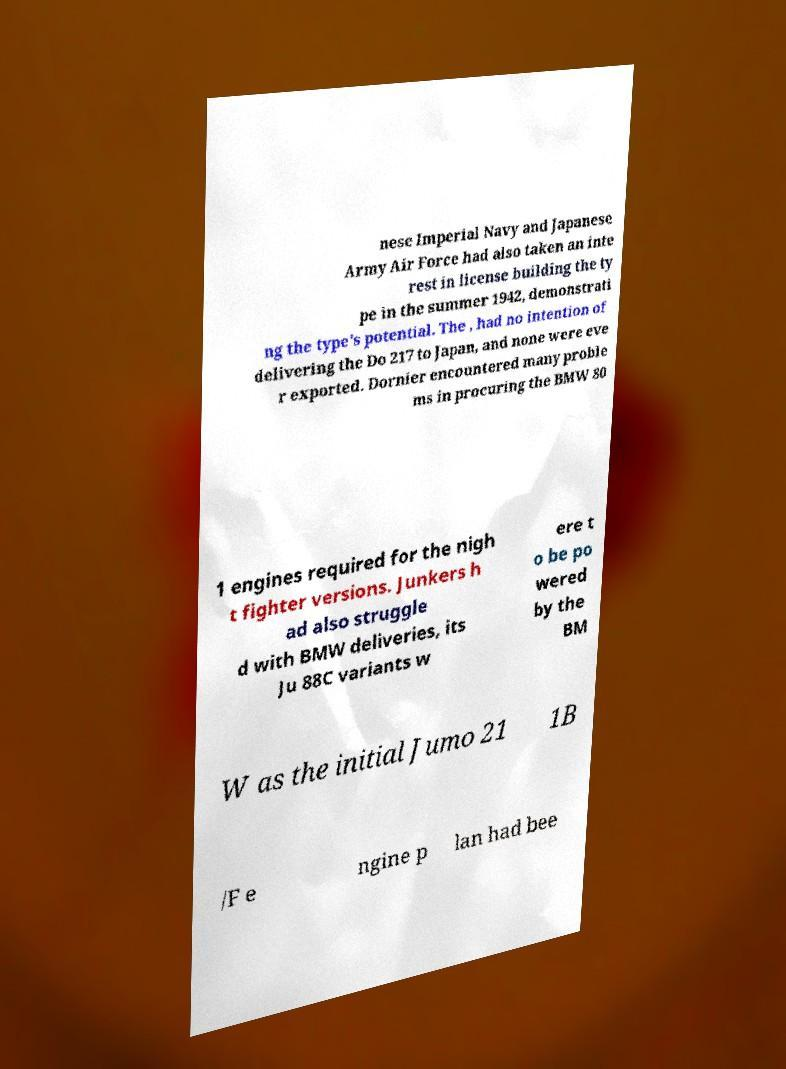There's text embedded in this image that I need extracted. Can you transcribe it verbatim? nese Imperial Navy and Japanese Army Air Force had also taken an inte rest in license building the ty pe in the summer 1942, demonstrati ng the type's potential. The , had no intention of delivering the Do 217 to Japan, and none were eve r exported. Dornier encountered many proble ms in procuring the BMW 80 1 engines required for the nigh t fighter versions. Junkers h ad also struggle d with BMW deliveries, its Ju 88C variants w ere t o be po wered by the BM W as the initial Jumo 21 1B /F e ngine p lan had bee 